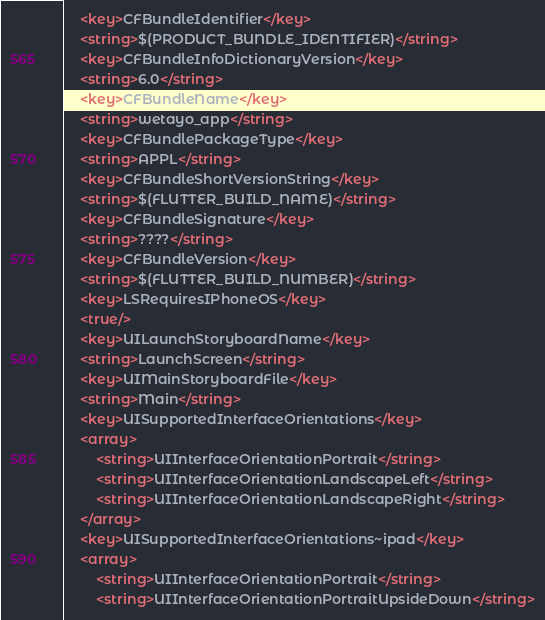Convert code to text. <code><loc_0><loc_0><loc_500><loc_500><_XML_>	<key>CFBundleIdentifier</key>
	<string>$(PRODUCT_BUNDLE_IDENTIFIER)</string>
	<key>CFBundleInfoDictionaryVersion</key>
	<string>6.0</string>
	<key>CFBundleName</key>
	<string>wetayo_app</string>
	<key>CFBundlePackageType</key>
	<string>APPL</string>
	<key>CFBundleShortVersionString</key>
	<string>$(FLUTTER_BUILD_NAME)</string>
	<key>CFBundleSignature</key>
	<string>????</string>
	<key>CFBundleVersion</key>
	<string>$(FLUTTER_BUILD_NUMBER)</string>
	<key>LSRequiresIPhoneOS</key>
	<true/>
	<key>UILaunchStoryboardName</key>
	<string>LaunchScreen</string>
	<key>UIMainStoryboardFile</key>
	<string>Main</string>
	<key>UISupportedInterfaceOrientations</key>
	<array>
		<string>UIInterfaceOrientationPortrait</string>
		<string>UIInterfaceOrientationLandscapeLeft</string>
		<string>UIInterfaceOrientationLandscapeRight</string>
	</array>
	<key>UISupportedInterfaceOrientations~ipad</key>
	<array>
		<string>UIInterfaceOrientationPortrait</string>
		<string>UIInterfaceOrientationPortraitUpsideDown</string></code> 